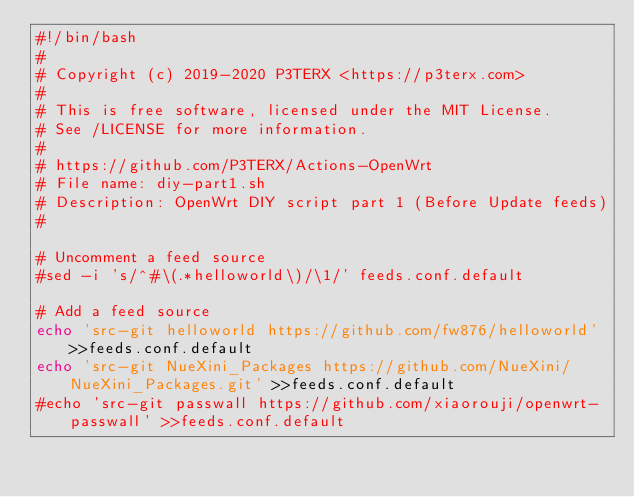Convert code to text. <code><loc_0><loc_0><loc_500><loc_500><_Bash_>#!/bin/bash
#
# Copyright (c) 2019-2020 P3TERX <https://p3terx.com>
#
# This is free software, licensed under the MIT License.
# See /LICENSE for more information.
#
# https://github.com/P3TERX/Actions-OpenWrt
# File name: diy-part1.sh
# Description: OpenWrt DIY script part 1 (Before Update feeds)
#

# Uncomment a feed source
#sed -i 's/^#\(.*helloworld\)/\1/' feeds.conf.default

# Add a feed source
echo 'src-git helloworld https://github.com/fw876/helloworld' >>feeds.conf.default
echo 'src-git NueXini_Packages https://github.com/NueXini/NueXini_Packages.git' >>feeds.conf.default
#echo 'src-git passwall https://github.com/xiaorouji/openwrt-passwall' >>feeds.conf.default
</code> 